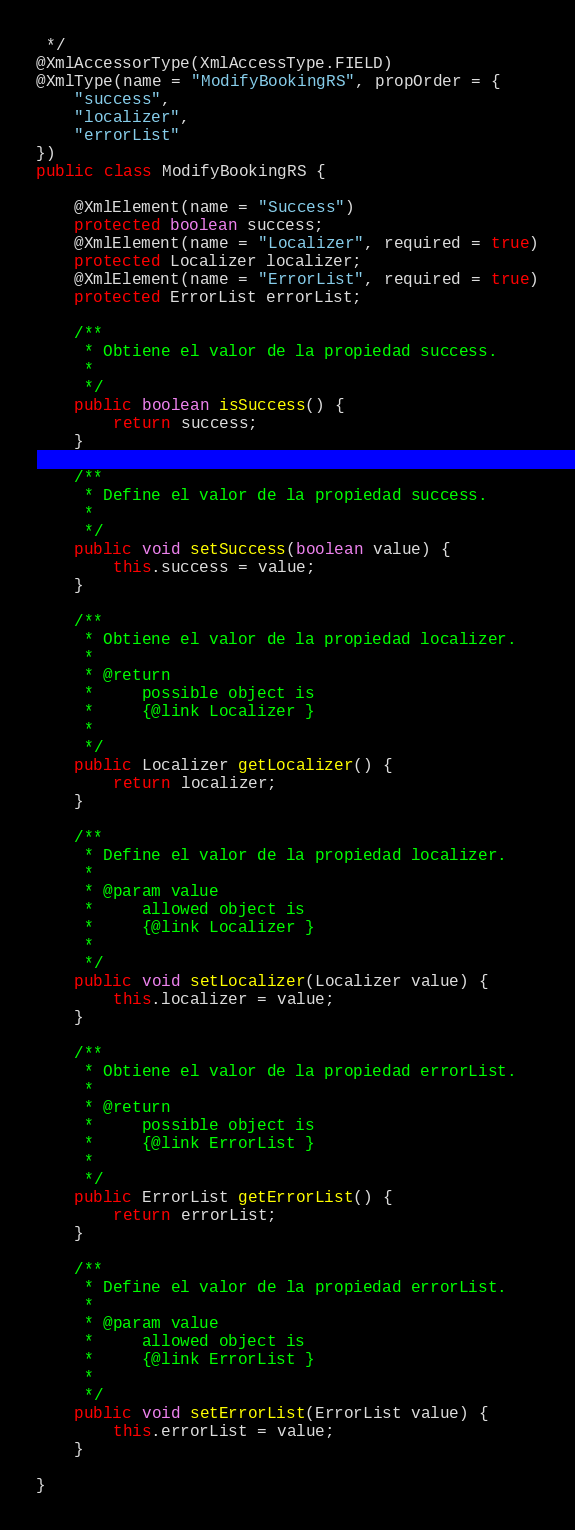<code> <loc_0><loc_0><loc_500><loc_500><_Java_> */
@XmlAccessorType(XmlAccessType.FIELD)
@XmlType(name = "ModifyBookingRS", propOrder = {
    "success",
    "localizer",
    "errorList"
})
public class ModifyBookingRS {

    @XmlElement(name = "Success")
    protected boolean success;
    @XmlElement(name = "Localizer", required = true)
    protected Localizer localizer;
    @XmlElement(name = "ErrorList", required = true)
    protected ErrorList errorList;

    /**
     * Obtiene el valor de la propiedad success.
     * 
     */
    public boolean isSuccess() {
        return success;
    }

    /**
     * Define el valor de la propiedad success.
     * 
     */
    public void setSuccess(boolean value) {
        this.success = value;
    }

    /**
     * Obtiene el valor de la propiedad localizer.
     * 
     * @return
     *     possible object is
     *     {@link Localizer }
     *     
     */
    public Localizer getLocalizer() {
        return localizer;
    }

    /**
     * Define el valor de la propiedad localizer.
     * 
     * @param value
     *     allowed object is
     *     {@link Localizer }
     *     
     */
    public void setLocalizer(Localizer value) {
        this.localizer = value;
    }

    /**
     * Obtiene el valor de la propiedad errorList.
     * 
     * @return
     *     possible object is
     *     {@link ErrorList }
     *     
     */
    public ErrorList getErrorList() {
        return errorList;
    }

    /**
     * Define el valor de la propiedad errorList.
     * 
     * @param value
     *     allowed object is
     *     {@link ErrorList }
     *     
     */
    public void setErrorList(ErrorList value) {
        this.errorList = value;
    }

}
</code> 